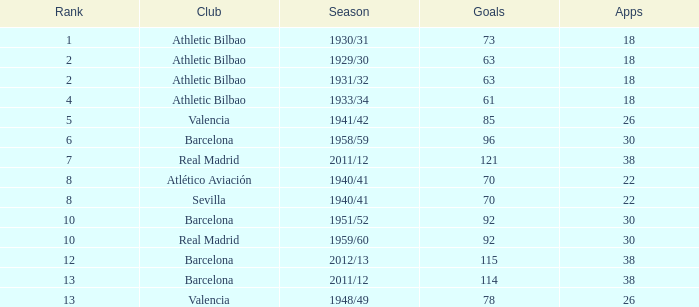Who was the club with fewer than 22 appearances and ranked below 2? Athletic Bilbao. 